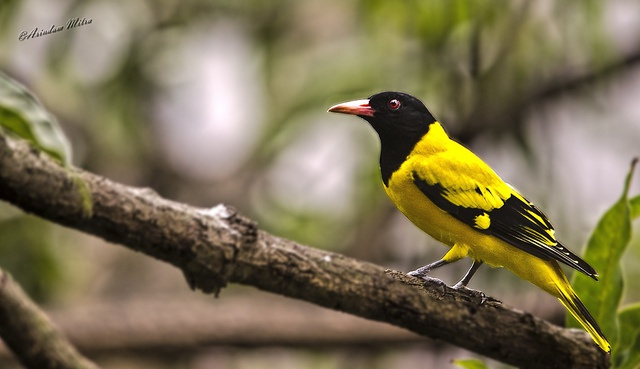Describe the objects in this image and their specific colors. I can see a bird in darkgreen, black, gold, and olive tones in this image. 